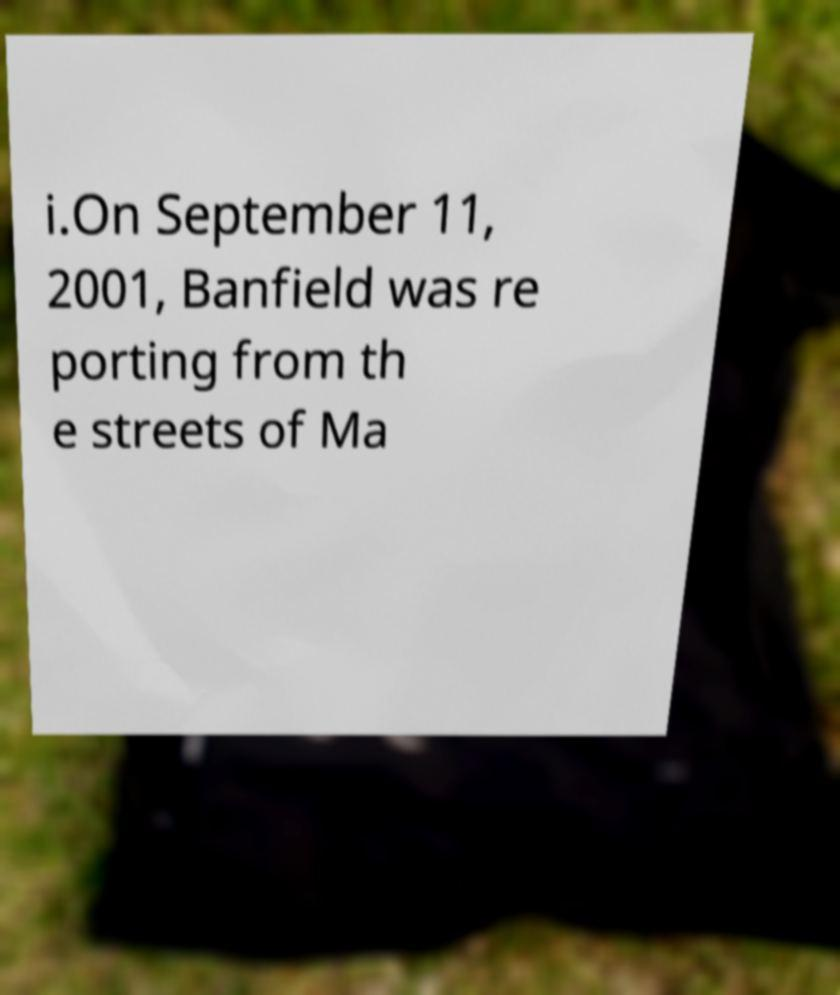Could you extract and type out the text from this image? i.On September 11, 2001, Banfield was re porting from th e streets of Ma 